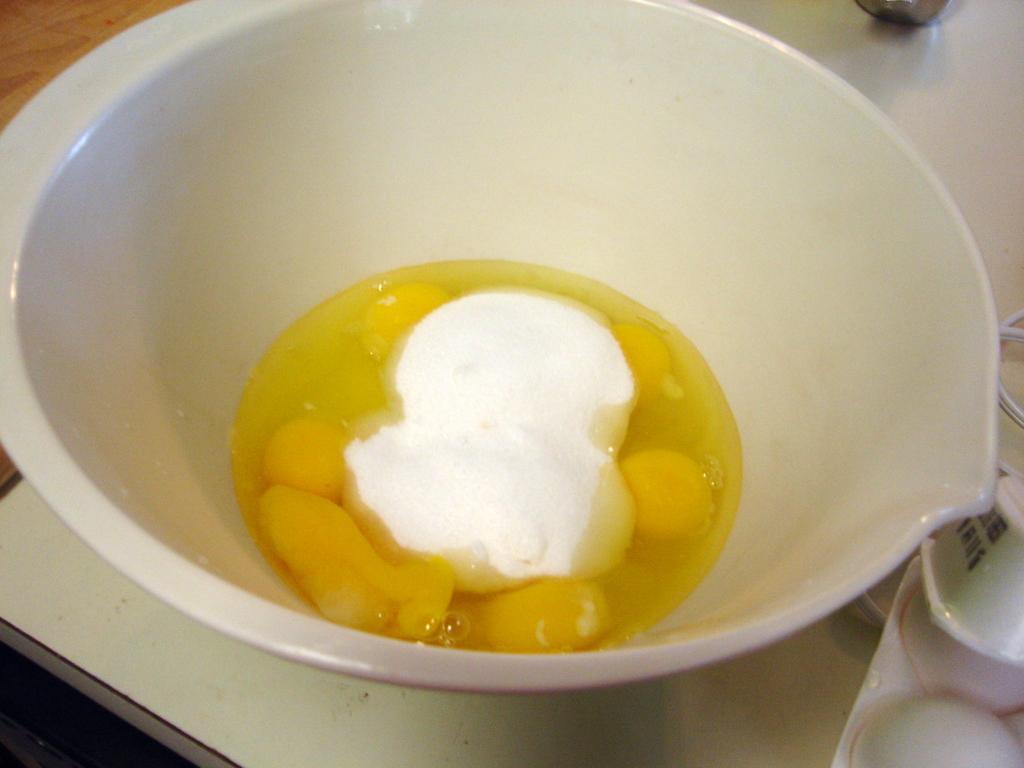Could you give a brief overview of what you see in this image? In this image we can see some food in a bowl which is placed on the table. 